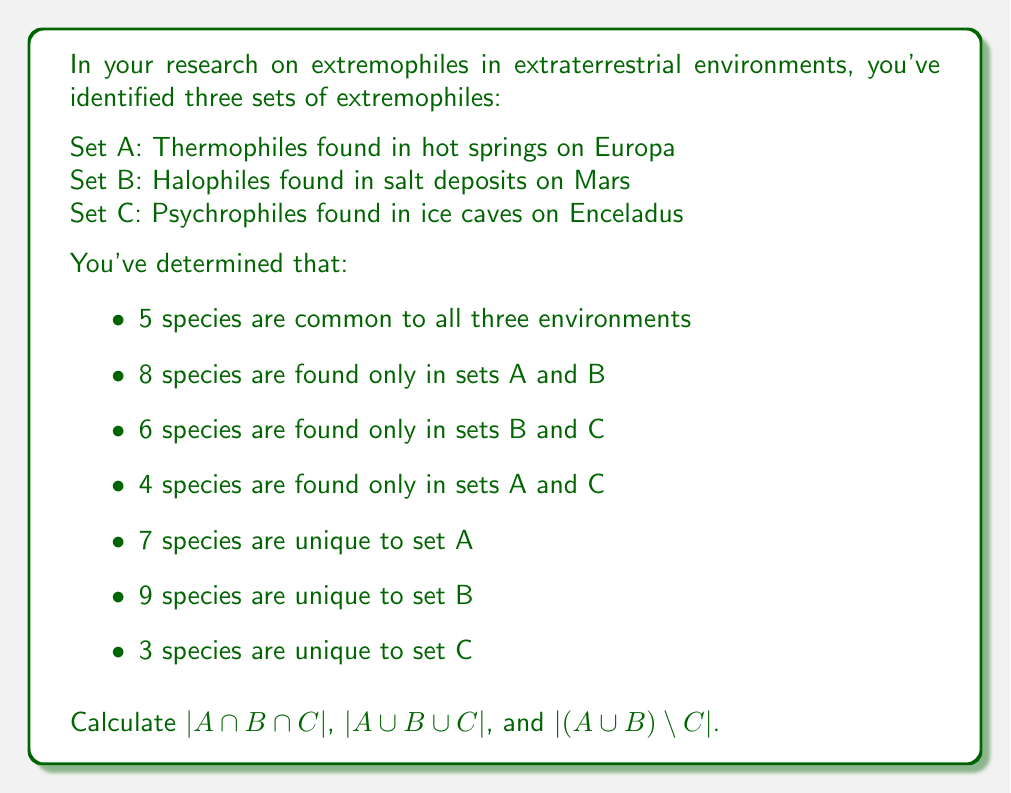Teach me how to tackle this problem. Let's approach this step-by-step using set theory principles:

1. First, let's visualize the problem using a Venn diagram:

[asy]
unitsize(1cm);

pair A = (0,0), B = (2,0), C = (1,1.7);
real r = 1.2;

path cA = circle(A, r);
path cB = circle(B, r);
path cC = circle(C, r);

fill(cA, rgb(1,0.7,0.7));
fill(cB, rgb(0.7,1,0.7));
fill(cC, rgb(0.7,0.7,1));

draw(cA);
draw(cB);
draw(cC);

label("A", A, SW);
label("B", B, SE);
label("C", C, N);

label("5", (1,0.6));
label("8", (1,-0.4));
label("4", (0.3,0.9));
label("6", (1.7,0.9));
label("7", (-0.6,0));
label("9", (2.6,0));
label("3", (1,2));

[/asy]

2. $|A \cap B \cap C| = 5$ (given in the question)

3. To find $|A \cup B \cup C|$, we need to sum all the values in the Venn diagram:

   $|A \cup B \cup C| = 5 + 8 + 6 + 4 + 7 + 9 + 3 = 42$

4. To find $|(A \cup B) \setminus C|$, we need to sum all the values in sets A and B that are not in C:

   $|(A \cup B) \setminus C| = 8 + 7 + 9 = 24$

Therefore, we have:
- $|A \cap B \cap C| = 5$
- $|A \cup B \cup C| = 42$
- $|(A \cup B) \setminus C| = 24$
Answer: $|A \cap B \cap C| = 5$
$|A \cup B \cup C| = 42$
$|(A \cup B) \setminus C| = 24$ 